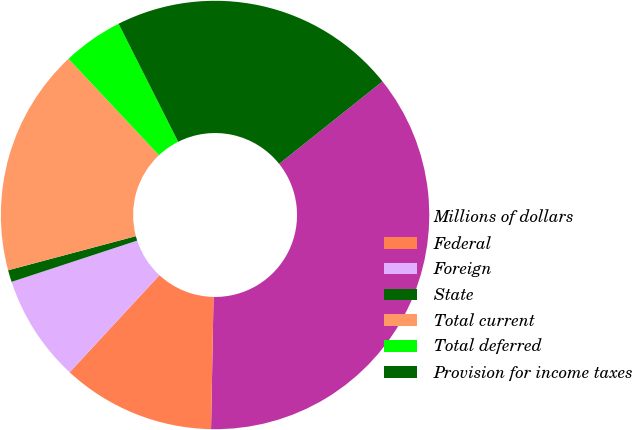<chart> <loc_0><loc_0><loc_500><loc_500><pie_chart><fcel>Millions of dollars<fcel>Federal<fcel>Foreign<fcel>State<fcel>Total current<fcel>Total deferred<fcel>Provision for income taxes<nl><fcel>36.02%<fcel>11.58%<fcel>8.07%<fcel>0.9%<fcel>17.16%<fcel>4.56%<fcel>21.72%<nl></chart> 